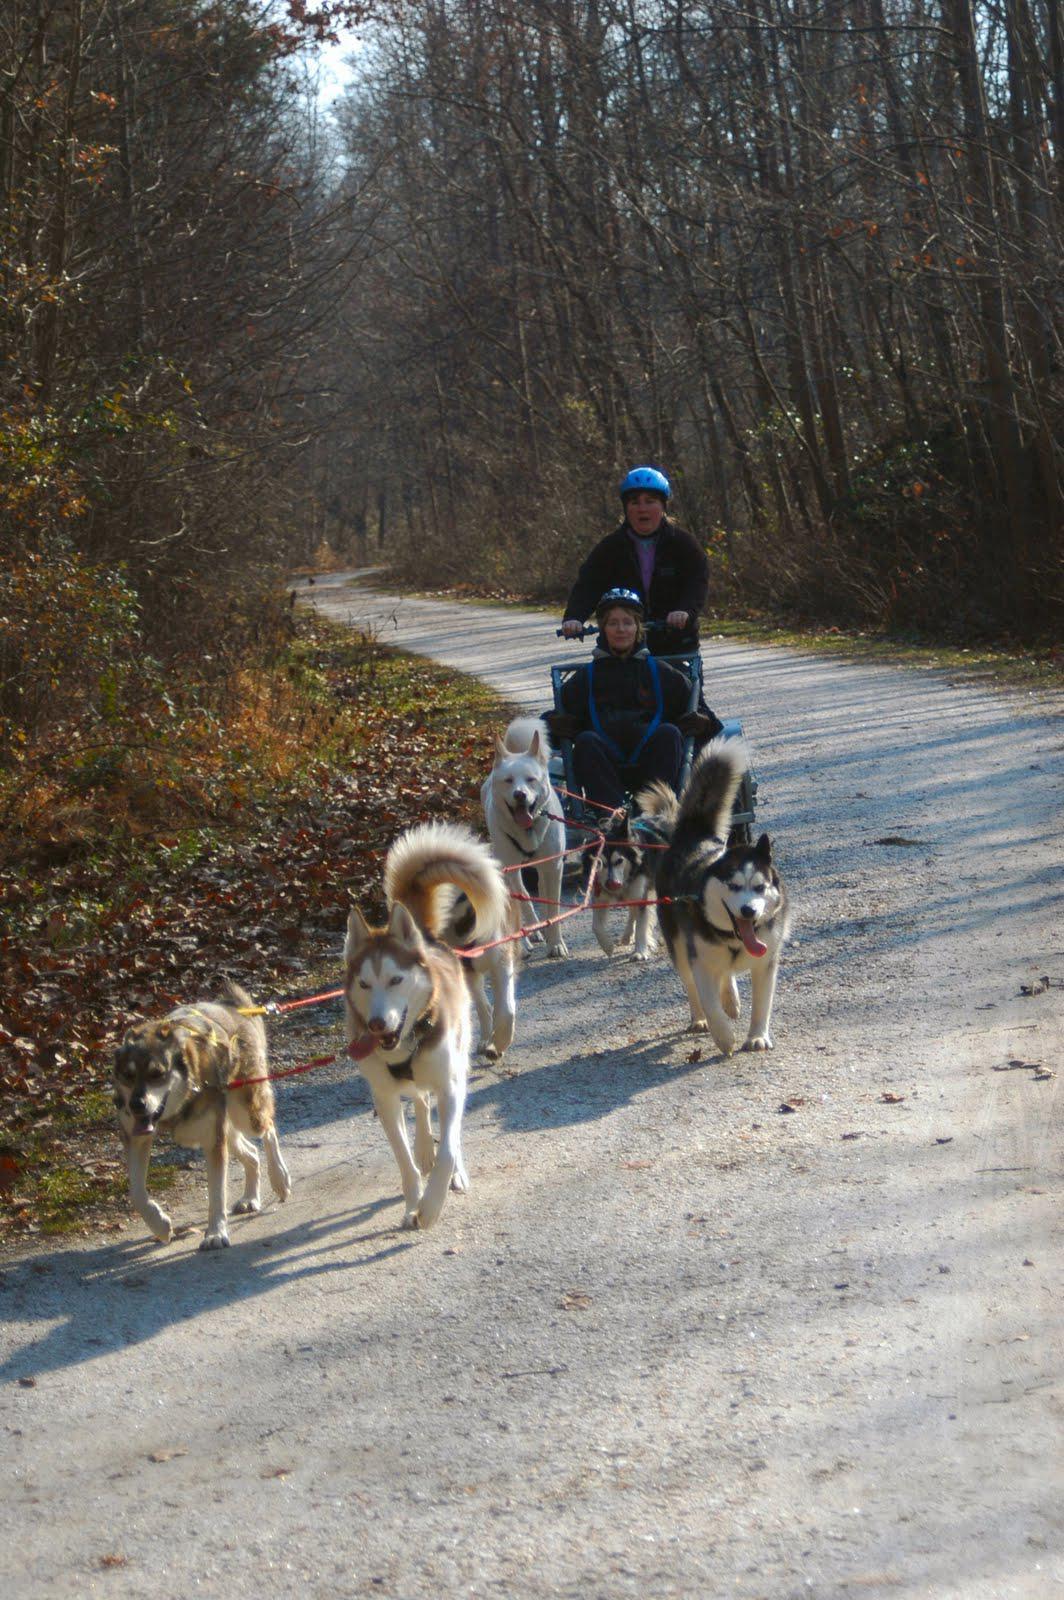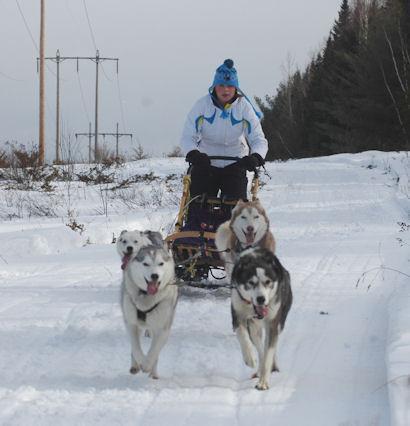The first image is the image on the left, the second image is the image on the right. Examine the images to the left and right. Is the description "A team of sled dogs is walking on a road that has no snow on it." accurate? Answer yes or no. Yes. The first image is the image on the left, the second image is the image on the right. Considering the images on both sides, is "sled dogs are pulling a wagon on a dirt road" valid? Answer yes or no. Yes. 